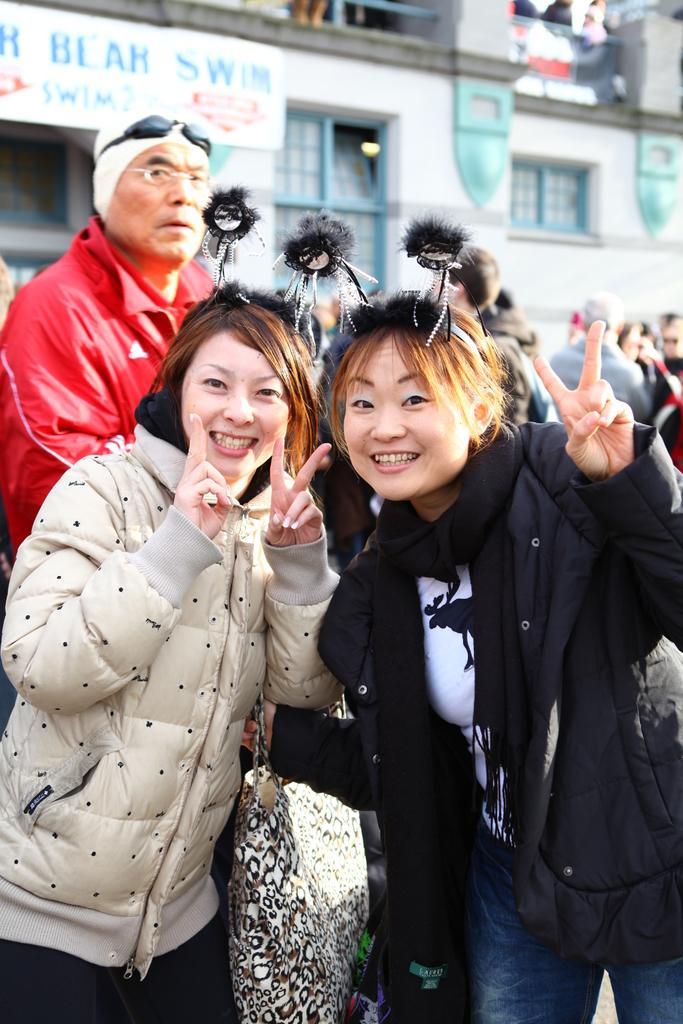Could you give a brief overview of what you see in this image? In this image there are two girls in the middle who are showing their fingers. In the background there are few other people standing on the floor. Behind them there is a building. 